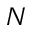Convert formula to latex. <formula><loc_0><loc_0><loc_500><loc_500>N</formula> 